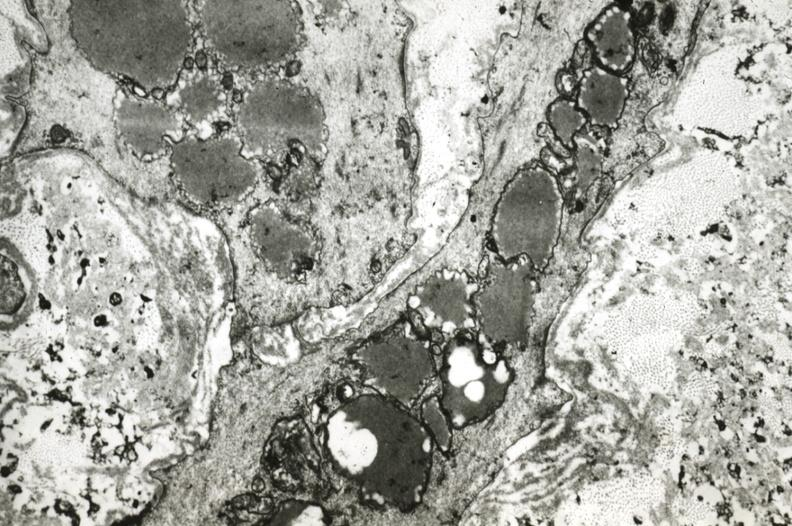s polycystic disease present?
Answer the question using a single word or phrase. No 